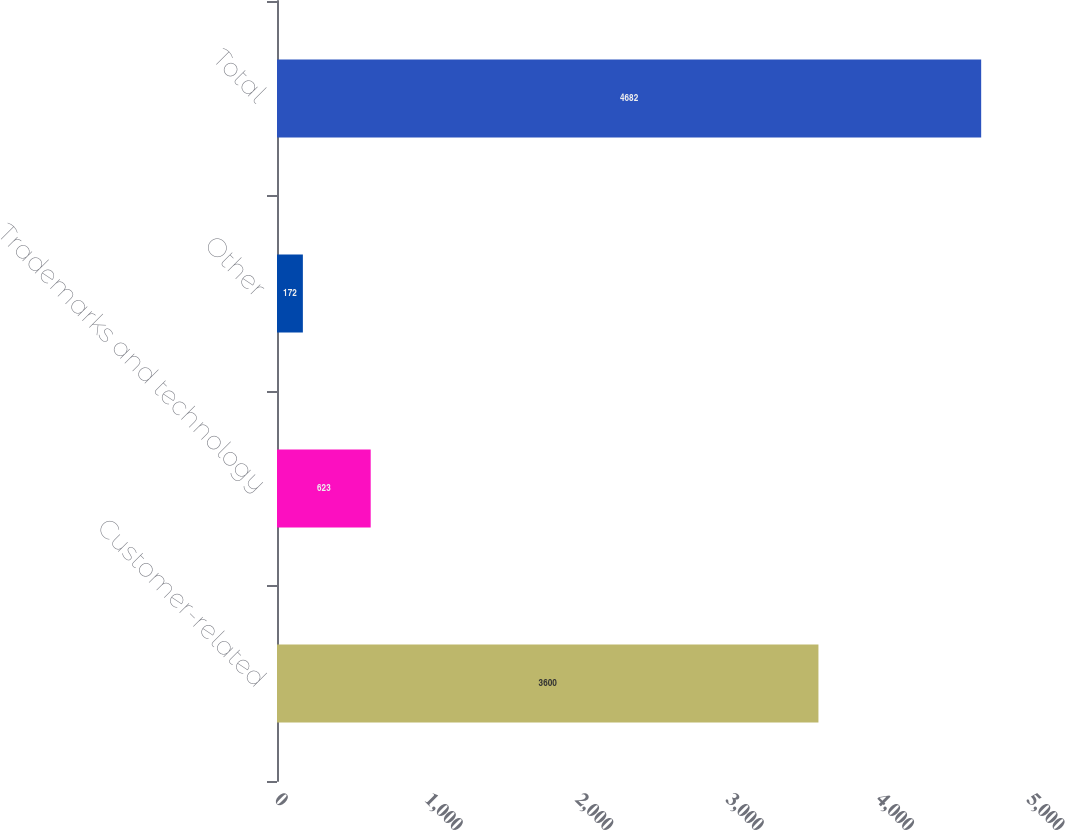Convert chart. <chart><loc_0><loc_0><loc_500><loc_500><bar_chart><fcel>Customer-related<fcel>Trademarks and technology<fcel>Other<fcel>Total<nl><fcel>3600<fcel>623<fcel>172<fcel>4682<nl></chart> 